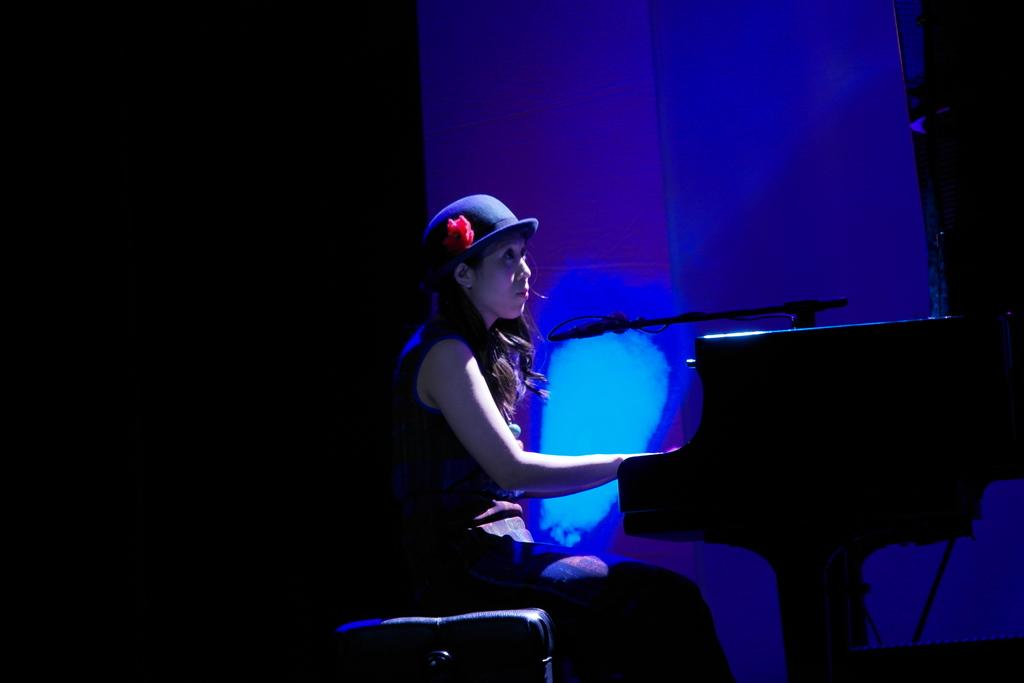What is the main subject in the image? There is a person sitting in the image. What else can be seen in the image besides the person? There is an object in the image. Can you describe the lighting in the background of the image? The background of the image has some light. What type of division is being discussed in the image? There is no division being discussed in the image; it features a person sitting and an object. What question is the person asking in the image? There is no question being asked in the image; the person is simply sitting. 